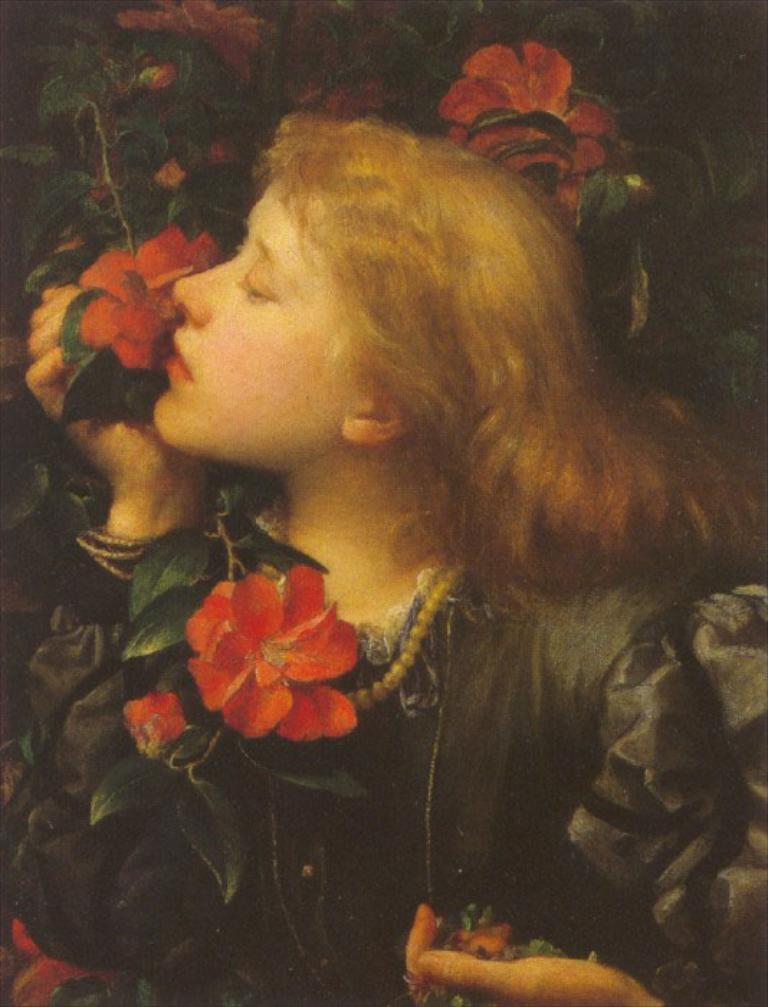Can you describe this image briefly? In this image I can see depiction picture where I can see a woman and few flowers. 